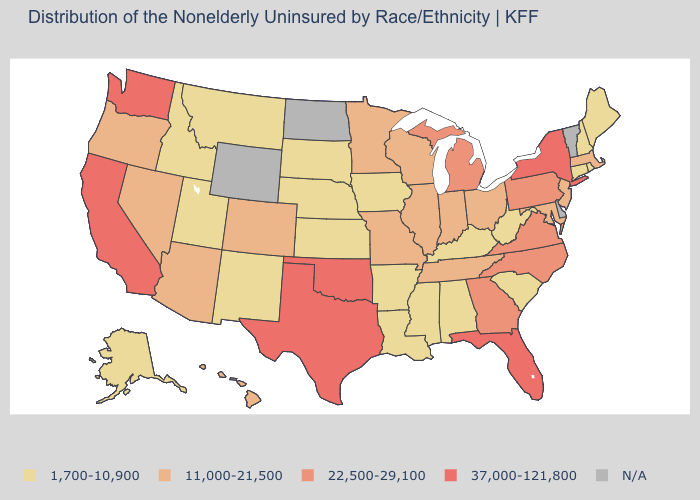Among the states that border New Mexico , does Utah have the highest value?
Quick response, please. No. Which states have the lowest value in the USA?
Short answer required. Alabama, Alaska, Arkansas, Connecticut, Idaho, Iowa, Kansas, Kentucky, Louisiana, Maine, Mississippi, Montana, Nebraska, New Hampshire, New Mexico, Rhode Island, South Carolina, South Dakota, Utah, West Virginia. What is the value of Virginia?
Give a very brief answer. 22,500-29,100. What is the value of Mississippi?
Short answer required. 1,700-10,900. Name the states that have a value in the range 11,000-21,500?
Be succinct. Arizona, Colorado, Hawaii, Illinois, Indiana, Maryland, Massachusetts, Minnesota, Missouri, Nevada, New Jersey, Ohio, Oregon, Tennessee, Wisconsin. What is the value of Nebraska?
Give a very brief answer. 1,700-10,900. Name the states that have a value in the range 22,500-29,100?
Be succinct. Georgia, Michigan, North Carolina, Pennsylvania, Virginia. What is the value of Idaho?
Be succinct. 1,700-10,900. What is the highest value in the USA?
Be succinct. 37,000-121,800. What is the value of Virginia?
Write a very short answer. 22,500-29,100. What is the value of Georgia?
Keep it brief. 22,500-29,100. Name the states that have a value in the range 37,000-121,800?
Concise answer only. California, Florida, New York, Oklahoma, Texas, Washington. What is the lowest value in states that border Maryland?
Short answer required. 1,700-10,900. Name the states that have a value in the range 11,000-21,500?
Give a very brief answer. Arizona, Colorado, Hawaii, Illinois, Indiana, Maryland, Massachusetts, Minnesota, Missouri, Nevada, New Jersey, Ohio, Oregon, Tennessee, Wisconsin. 